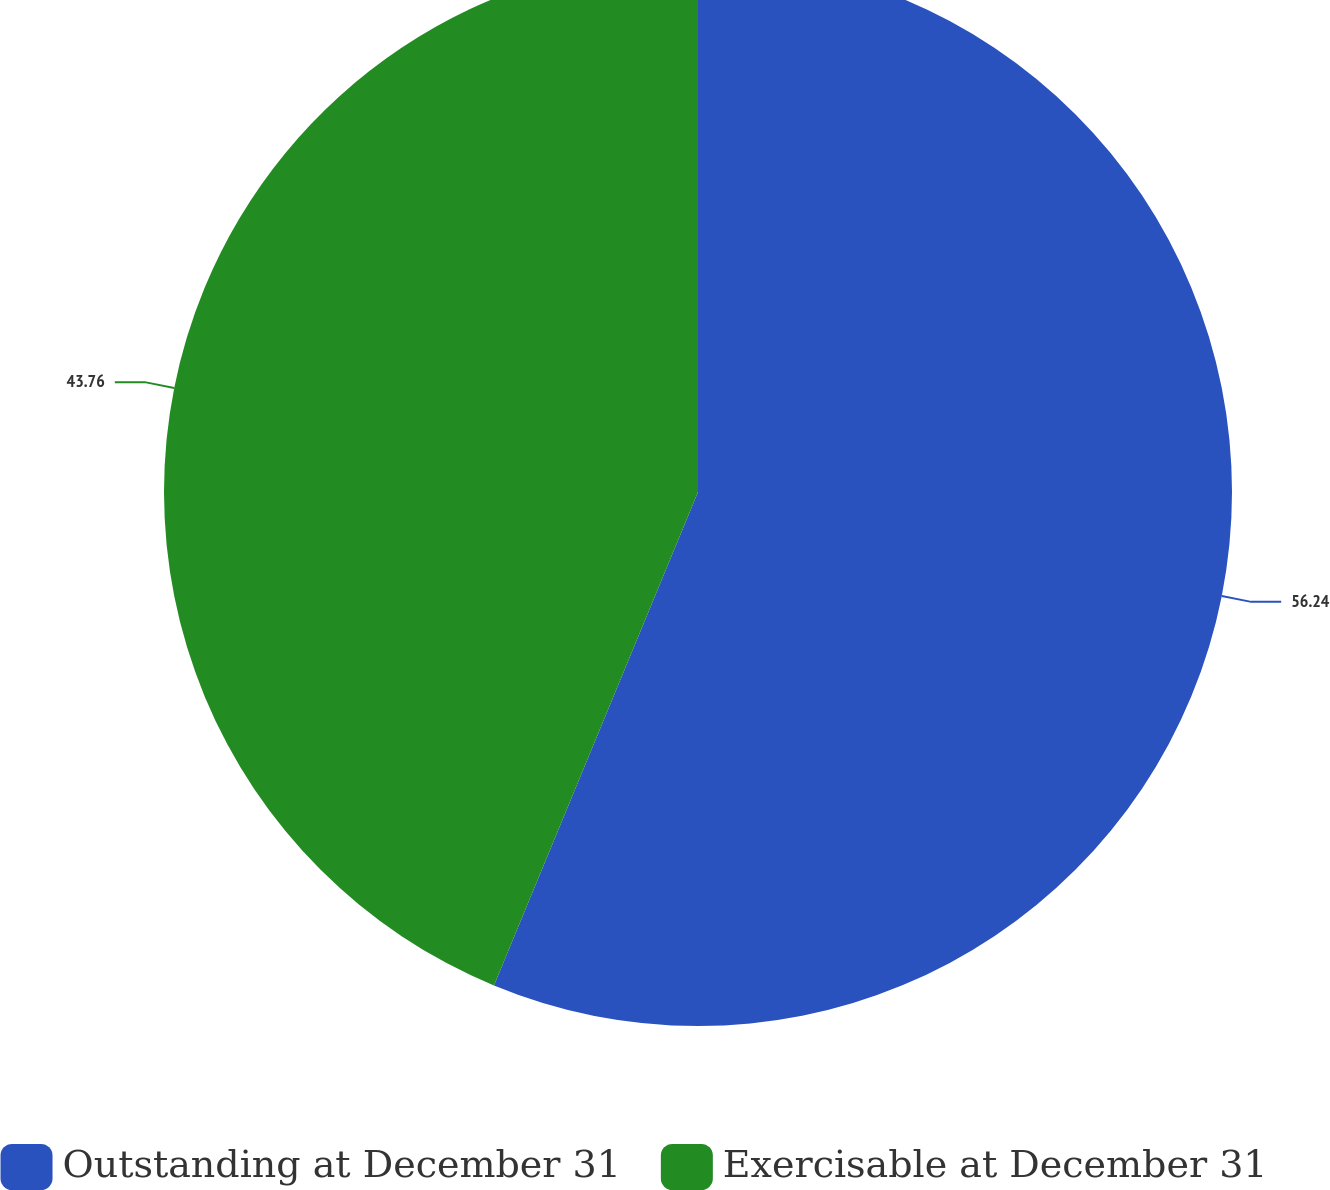Convert chart to OTSL. <chart><loc_0><loc_0><loc_500><loc_500><pie_chart><fcel>Outstanding at December 31<fcel>Exercisable at December 31<nl><fcel>56.24%<fcel>43.76%<nl></chart> 